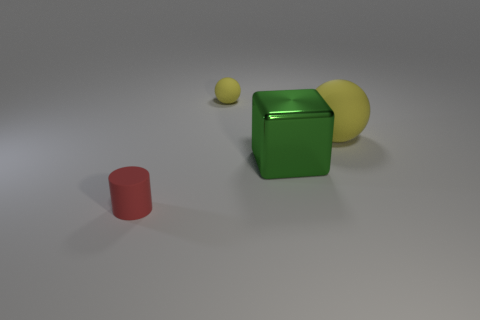Add 2 large yellow objects. How many objects exist? 6 Subtract all cylinders. How many objects are left? 3 Subtract all tiny balls. Subtract all large green matte blocks. How many objects are left? 3 Add 1 cylinders. How many cylinders are left? 2 Add 4 gray balls. How many gray balls exist? 4 Subtract 0 purple blocks. How many objects are left? 4 Subtract 2 spheres. How many spheres are left? 0 Subtract all red blocks. Subtract all green balls. How many blocks are left? 1 Subtract all purple cylinders. How many brown spheres are left? 0 